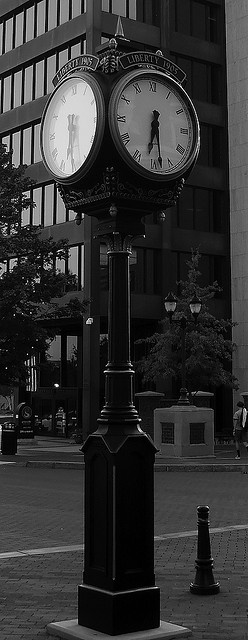Describe the objects in this image and their specific colors. I can see clock in gray, black, and lightgray tones, clock in gray, lightgray, darkgray, and black tones, people in gray, black, darkgray, and lightgray tones, and car in black and gray tones in this image. 